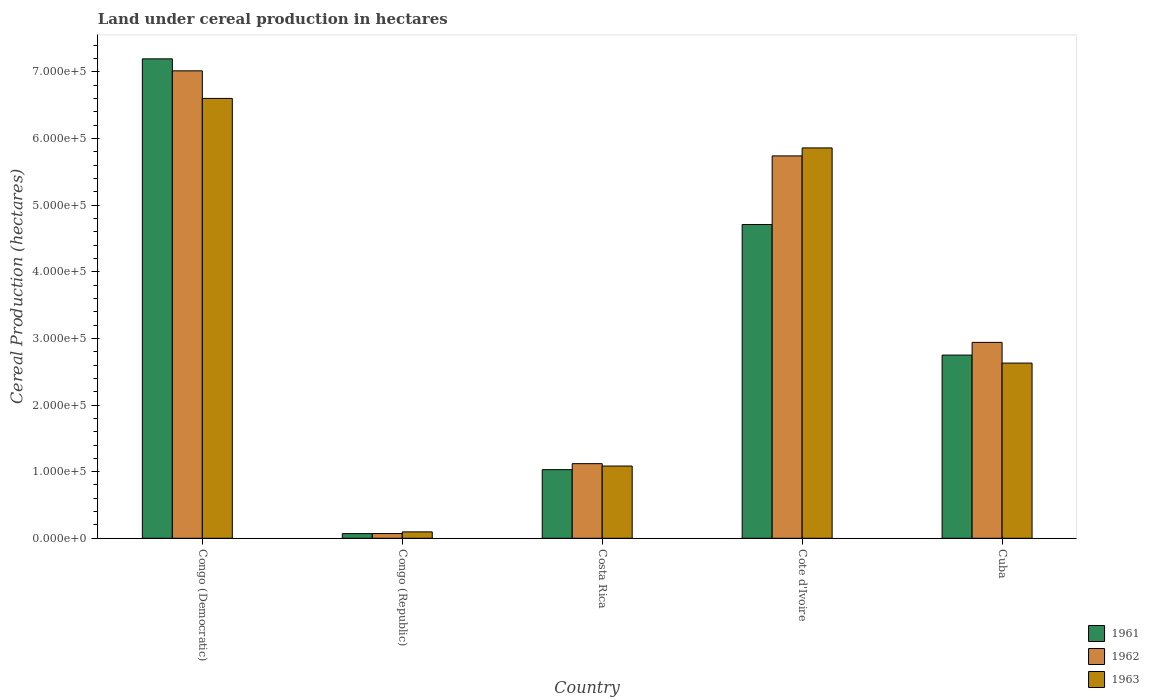How many groups of bars are there?
Make the answer very short. 5. Are the number of bars per tick equal to the number of legend labels?
Provide a short and direct response. Yes. How many bars are there on the 1st tick from the right?
Provide a succinct answer. 3. What is the label of the 2nd group of bars from the left?
Keep it short and to the point. Congo (Republic). What is the land under cereal production in 1962 in Cote d'Ivoire?
Your answer should be compact. 5.74e+05. Across all countries, what is the maximum land under cereal production in 1961?
Provide a succinct answer. 7.20e+05. Across all countries, what is the minimum land under cereal production in 1963?
Keep it short and to the point. 9600. In which country was the land under cereal production in 1961 maximum?
Give a very brief answer. Congo (Democratic). In which country was the land under cereal production in 1962 minimum?
Give a very brief answer. Congo (Republic). What is the total land under cereal production in 1961 in the graph?
Offer a very short reply. 1.58e+06. What is the difference between the land under cereal production in 1963 in Congo (Democratic) and that in Cote d'Ivoire?
Your answer should be compact. 7.43e+04. What is the difference between the land under cereal production in 1963 in Congo (Democratic) and the land under cereal production in 1961 in Costa Rica?
Provide a short and direct response. 5.57e+05. What is the average land under cereal production in 1963 per country?
Offer a very short reply. 3.25e+05. What is the difference between the land under cereal production of/in 1963 and land under cereal production of/in 1962 in Congo (Democratic)?
Offer a terse response. -4.14e+04. What is the ratio of the land under cereal production in 1962 in Congo (Republic) to that in Cuba?
Provide a succinct answer. 0.02. Is the difference between the land under cereal production in 1963 in Congo (Democratic) and Congo (Republic) greater than the difference between the land under cereal production in 1962 in Congo (Democratic) and Congo (Republic)?
Your response must be concise. No. What is the difference between the highest and the second highest land under cereal production in 1961?
Your answer should be compact. 1.96e+05. What is the difference between the highest and the lowest land under cereal production in 1962?
Offer a very short reply. 6.95e+05. What does the 3rd bar from the left in Cuba represents?
Provide a succinct answer. 1963. What does the 3rd bar from the right in Congo (Democratic) represents?
Make the answer very short. 1961. Is it the case that in every country, the sum of the land under cereal production in 1961 and land under cereal production in 1962 is greater than the land under cereal production in 1963?
Your answer should be compact. Yes. How many countries are there in the graph?
Offer a terse response. 5. What is the difference between two consecutive major ticks on the Y-axis?
Offer a terse response. 1.00e+05. Are the values on the major ticks of Y-axis written in scientific E-notation?
Your response must be concise. Yes. Does the graph contain any zero values?
Provide a succinct answer. No. Does the graph contain grids?
Offer a very short reply. No. Where does the legend appear in the graph?
Your answer should be compact. Bottom right. What is the title of the graph?
Provide a short and direct response. Land under cereal production in hectares. What is the label or title of the Y-axis?
Your answer should be very brief. Cereal Production (hectares). What is the Cereal Production (hectares) in 1961 in Congo (Democratic)?
Your answer should be very brief. 7.20e+05. What is the Cereal Production (hectares) of 1962 in Congo (Democratic)?
Ensure brevity in your answer.  7.02e+05. What is the Cereal Production (hectares) of 1963 in Congo (Democratic)?
Make the answer very short. 6.60e+05. What is the Cereal Production (hectares) in 1961 in Congo (Republic)?
Your response must be concise. 7000. What is the Cereal Production (hectares) in 1962 in Congo (Republic)?
Provide a succinct answer. 7100. What is the Cereal Production (hectares) in 1963 in Congo (Republic)?
Your answer should be compact. 9600. What is the Cereal Production (hectares) in 1961 in Costa Rica?
Provide a succinct answer. 1.03e+05. What is the Cereal Production (hectares) of 1962 in Costa Rica?
Offer a very short reply. 1.12e+05. What is the Cereal Production (hectares) of 1963 in Costa Rica?
Your answer should be compact. 1.08e+05. What is the Cereal Production (hectares) of 1961 in Cote d'Ivoire?
Give a very brief answer. 4.71e+05. What is the Cereal Production (hectares) of 1962 in Cote d'Ivoire?
Your answer should be very brief. 5.74e+05. What is the Cereal Production (hectares) of 1963 in Cote d'Ivoire?
Provide a short and direct response. 5.86e+05. What is the Cereal Production (hectares) in 1961 in Cuba?
Ensure brevity in your answer.  2.75e+05. What is the Cereal Production (hectares) of 1962 in Cuba?
Your answer should be compact. 2.94e+05. What is the Cereal Production (hectares) of 1963 in Cuba?
Give a very brief answer. 2.63e+05. Across all countries, what is the maximum Cereal Production (hectares) in 1961?
Provide a short and direct response. 7.20e+05. Across all countries, what is the maximum Cereal Production (hectares) of 1962?
Provide a short and direct response. 7.02e+05. Across all countries, what is the maximum Cereal Production (hectares) of 1963?
Your answer should be very brief. 6.60e+05. Across all countries, what is the minimum Cereal Production (hectares) in 1961?
Provide a short and direct response. 7000. Across all countries, what is the minimum Cereal Production (hectares) in 1962?
Make the answer very short. 7100. Across all countries, what is the minimum Cereal Production (hectares) of 1963?
Offer a very short reply. 9600. What is the total Cereal Production (hectares) in 1961 in the graph?
Provide a short and direct response. 1.58e+06. What is the total Cereal Production (hectares) of 1962 in the graph?
Your response must be concise. 1.69e+06. What is the total Cereal Production (hectares) of 1963 in the graph?
Offer a terse response. 1.63e+06. What is the difference between the Cereal Production (hectares) in 1961 in Congo (Democratic) and that in Congo (Republic)?
Your response must be concise. 7.13e+05. What is the difference between the Cereal Production (hectares) of 1962 in Congo (Democratic) and that in Congo (Republic)?
Provide a short and direct response. 6.95e+05. What is the difference between the Cereal Production (hectares) in 1963 in Congo (Democratic) and that in Congo (Republic)?
Keep it short and to the point. 6.51e+05. What is the difference between the Cereal Production (hectares) of 1961 in Congo (Democratic) and that in Costa Rica?
Give a very brief answer. 6.17e+05. What is the difference between the Cereal Production (hectares) in 1962 in Congo (Democratic) and that in Costa Rica?
Your response must be concise. 5.90e+05. What is the difference between the Cereal Production (hectares) of 1963 in Congo (Democratic) and that in Costa Rica?
Offer a very short reply. 5.52e+05. What is the difference between the Cereal Production (hectares) in 1961 in Congo (Democratic) and that in Cote d'Ivoire?
Ensure brevity in your answer.  2.49e+05. What is the difference between the Cereal Production (hectares) in 1962 in Congo (Democratic) and that in Cote d'Ivoire?
Your response must be concise. 1.28e+05. What is the difference between the Cereal Production (hectares) of 1963 in Congo (Democratic) and that in Cote d'Ivoire?
Your response must be concise. 7.43e+04. What is the difference between the Cereal Production (hectares) of 1961 in Congo (Democratic) and that in Cuba?
Ensure brevity in your answer.  4.45e+05. What is the difference between the Cereal Production (hectares) in 1962 in Congo (Democratic) and that in Cuba?
Your answer should be very brief. 4.08e+05. What is the difference between the Cereal Production (hectares) of 1963 in Congo (Democratic) and that in Cuba?
Provide a short and direct response. 3.97e+05. What is the difference between the Cereal Production (hectares) of 1961 in Congo (Republic) and that in Costa Rica?
Provide a short and direct response. -9.60e+04. What is the difference between the Cereal Production (hectares) of 1962 in Congo (Republic) and that in Costa Rica?
Offer a terse response. -1.05e+05. What is the difference between the Cereal Production (hectares) of 1963 in Congo (Republic) and that in Costa Rica?
Give a very brief answer. -9.88e+04. What is the difference between the Cereal Production (hectares) of 1961 in Congo (Republic) and that in Cote d'Ivoire?
Your answer should be very brief. -4.64e+05. What is the difference between the Cereal Production (hectares) in 1962 in Congo (Republic) and that in Cote d'Ivoire?
Offer a terse response. -5.67e+05. What is the difference between the Cereal Production (hectares) of 1963 in Congo (Republic) and that in Cote d'Ivoire?
Offer a terse response. -5.76e+05. What is the difference between the Cereal Production (hectares) of 1961 in Congo (Republic) and that in Cuba?
Your answer should be very brief. -2.68e+05. What is the difference between the Cereal Production (hectares) in 1962 in Congo (Republic) and that in Cuba?
Offer a terse response. -2.87e+05. What is the difference between the Cereal Production (hectares) of 1963 in Congo (Republic) and that in Cuba?
Offer a very short reply. -2.53e+05. What is the difference between the Cereal Production (hectares) of 1961 in Costa Rica and that in Cote d'Ivoire?
Offer a terse response. -3.68e+05. What is the difference between the Cereal Production (hectares) of 1962 in Costa Rica and that in Cote d'Ivoire?
Your answer should be compact. -4.62e+05. What is the difference between the Cereal Production (hectares) in 1963 in Costa Rica and that in Cote d'Ivoire?
Your response must be concise. -4.78e+05. What is the difference between the Cereal Production (hectares) of 1961 in Costa Rica and that in Cuba?
Your answer should be compact. -1.72e+05. What is the difference between the Cereal Production (hectares) of 1962 in Costa Rica and that in Cuba?
Provide a short and direct response. -1.82e+05. What is the difference between the Cereal Production (hectares) in 1963 in Costa Rica and that in Cuba?
Offer a very short reply. -1.55e+05. What is the difference between the Cereal Production (hectares) in 1961 in Cote d'Ivoire and that in Cuba?
Offer a very short reply. 1.96e+05. What is the difference between the Cereal Production (hectares) in 1962 in Cote d'Ivoire and that in Cuba?
Keep it short and to the point. 2.80e+05. What is the difference between the Cereal Production (hectares) of 1963 in Cote d'Ivoire and that in Cuba?
Make the answer very short. 3.23e+05. What is the difference between the Cereal Production (hectares) in 1961 in Congo (Democratic) and the Cereal Production (hectares) in 1962 in Congo (Republic)?
Offer a terse response. 7.13e+05. What is the difference between the Cereal Production (hectares) in 1961 in Congo (Democratic) and the Cereal Production (hectares) in 1963 in Congo (Republic)?
Ensure brevity in your answer.  7.10e+05. What is the difference between the Cereal Production (hectares) of 1962 in Congo (Democratic) and the Cereal Production (hectares) of 1963 in Congo (Republic)?
Ensure brevity in your answer.  6.92e+05. What is the difference between the Cereal Production (hectares) of 1961 in Congo (Democratic) and the Cereal Production (hectares) of 1962 in Costa Rica?
Offer a very short reply. 6.08e+05. What is the difference between the Cereal Production (hectares) of 1961 in Congo (Democratic) and the Cereal Production (hectares) of 1963 in Costa Rica?
Give a very brief answer. 6.11e+05. What is the difference between the Cereal Production (hectares) of 1962 in Congo (Democratic) and the Cereal Production (hectares) of 1963 in Costa Rica?
Your response must be concise. 5.93e+05. What is the difference between the Cereal Production (hectares) of 1961 in Congo (Democratic) and the Cereal Production (hectares) of 1962 in Cote d'Ivoire?
Your answer should be compact. 1.46e+05. What is the difference between the Cereal Production (hectares) in 1961 in Congo (Democratic) and the Cereal Production (hectares) in 1963 in Cote d'Ivoire?
Offer a terse response. 1.34e+05. What is the difference between the Cereal Production (hectares) in 1962 in Congo (Democratic) and the Cereal Production (hectares) in 1963 in Cote d'Ivoire?
Offer a very short reply. 1.16e+05. What is the difference between the Cereal Production (hectares) of 1961 in Congo (Democratic) and the Cereal Production (hectares) of 1962 in Cuba?
Your answer should be very brief. 4.26e+05. What is the difference between the Cereal Production (hectares) in 1961 in Congo (Democratic) and the Cereal Production (hectares) in 1963 in Cuba?
Offer a terse response. 4.57e+05. What is the difference between the Cereal Production (hectares) in 1962 in Congo (Democratic) and the Cereal Production (hectares) in 1963 in Cuba?
Your answer should be compact. 4.39e+05. What is the difference between the Cereal Production (hectares) in 1961 in Congo (Republic) and the Cereal Production (hectares) in 1962 in Costa Rica?
Your answer should be compact. -1.05e+05. What is the difference between the Cereal Production (hectares) of 1961 in Congo (Republic) and the Cereal Production (hectares) of 1963 in Costa Rica?
Make the answer very short. -1.01e+05. What is the difference between the Cereal Production (hectares) in 1962 in Congo (Republic) and the Cereal Production (hectares) in 1963 in Costa Rica?
Your answer should be very brief. -1.01e+05. What is the difference between the Cereal Production (hectares) in 1961 in Congo (Republic) and the Cereal Production (hectares) in 1962 in Cote d'Ivoire?
Make the answer very short. -5.67e+05. What is the difference between the Cereal Production (hectares) in 1961 in Congo (Republic) and the Cereal Production (hectares) in 1963 in Cote d'Ivoire?
Make the answer very short. -5.79e+05. What is the difference between the Cereal Production (hectares) of 1962 in Congo (Republic) and the Cereal Production (hectares) of 1963 in Cote d'Ivoire?
Your answer should be very brief. -5.79e+05. What is the difference between the Cereal Production (hectares) of 1961 in Congo (Republic) and the Cereal Production (hectares) of 1962 in Cuba?
Your response must be concise. -2.87e+05. What is the difference between the Cereal Production (hectares) of 1961 in Congo (Republic) and the Cereal Production (hectares) of 1963 in Cuba?
Keep it short and to the point. -2.56e+05. What is the difference between the Cereal Production (hectares) in 1962 in Congo (Republic) and the Cereal Production (hectares) in 1963 in Cuba?
Your answer should be compact. -2.56e+05. What is the difference between the Cereal Production (hectares) in 1961 in Costa Rica and the Cereal Production (hectares) in 1962 in Cote d'Ivoire?
Provide a short and direct response. -4.71e+05. What is the difference between the Cereal Production (hectares) of 1961 in Costa Rica and the Cereal Production (hectares) of 1963 in Cote d'Ivoire?
Keep it short and to the point. -4.83e+05. What is the difference between the Cereal Production (hectares) of 1962 in Costa Rica and the Cereal Production (hectares) of 1963 in Cote d'Ivoire?
Ensure brevity in your answer.  -4.74e+05. What is the difference between the Cereal Production (hectares) in 1961 in Costa Rica and the Cereal Production (hectares) in 1962 in Cuba?
Ensure brevity in your answer.  -1.91e+05. What is the difference between the Cereal Production (hectares) in 1961 in Costa Rica and the Cereal Production (hectares) in 1963 in Cuba?
Provide a short and direct response. -1.60e+05. What is the difference between the Cereal Production (hectares) of 1962 in Costa Rica and the Cereal Production (hectares) of 1963 in Cuba?
Give a very brief answer. -1.51e+05. What is the difference between the Cereal Production (hectares) in 1961 in Cote d'Ivoire and the Cereal Production (hectares) in 1962 in Cuba?
Provide a succinct answer. 1.77e+05. What is the difference between the Cereal Production (hectares) in 1961 in Cote d'Ivoire and the Cereal Production (hectares) in 1963 in Cuba?
Offer a very short reply. 2.08e+05. What is the difference between the Cereal Production (hectares) of 1962 in Cote d'Ivoire and the Cereal Production (hectares) of 1963 in Cuba?
Your answer should be compact. 3.11e+05. What is the average Cereal Production (hectares) in 1961 per country?
Your answer should be compact. 3.15e+05. What is the average Cereal Production (hectares) of 1962 per country?
Your answer should be compact. 3.38e+05. What is the average Cereal Production (hectares) in 1963 per country?
Offer a very short reply. 3.25e+05. What is the difference between the Cereal Production (hectares) of 1961 and Cereal Production (hectares) of 1962 in Congo (Democratic)?
Provide a succinct answer. 1.80e+04. What is the difference between the Cereal Production (hectares) of 1961 and Cereal Production (hectares) of 1963 in Congo (Democratic)?
Offer a terse response. 5.94e+04. What is the difference between the Cereal Production (hectares) of 1962 and Cereal Production (hectares) of 1963 in Congo (Democratic)?
Provide a short and direct response. 4.14e+04. What is the difference between the Cereal Production (hectares) of 1961 and Cereal Production (hectares) of 1962 in Congo (Republic)?
Your response must be concise. -100. What is the difference between the Cereal Production (hectares) of 1961 and Cereal Production (hectares) of 1963 in Congo (Republic)?
Offer a terse response. -2600. What is the difference between the Cereal Production (hectares) of 1962 and Cereal Production (hectares) of 1963 in Congo (Republic)?
Your response must be concise. -2500. What is the difference between the Cereal Production (hectares) of 1961 and Cereal Production (hectares) of 1962 in Costa Rica?
Your answer should be compact. -9000. What is the difference between the Cereal Production (hectares) in 1961 and Cereal Production (hectares) in 1963 in Costa Rica?
Provide a succinct answer. -5450. What is the difference between the Cereal Production (hectares) in 1962 and Cereal Production (hectares) in 1963 in Costa Rica?
Provide a succinct answer. 3550. What is the difference between the Cereal Production (hectares) of 1961 and Cereal Production (hectares) of 1962 in Cote d'Ivoire?
Offer a terse response. -1.03e+05. What is the difference between the Cereal Production (hectares) of 1961 and Cereal Production (hectares) of 1963 in Cote d'Ivoire?
Your answer should be compact. -1.15e+05. What is the difference between the Cereal Production (hectares) of 1962 and Cereal Production (hectares) of 1963 in Cote d'Ivoire?
Your response must be concise. -1.20e+04. What is the difference between the Cereal Production (hectares) in 1961 and Cereal Production (hectares) in 1962 in Cuba?
Offer a very short reply. -1.91e+04. What is the difference between the Cereal Production (hectares) of 1961 and Cereal Production (hectares) of 1963 in Cuba?
Provide a succinct answer. 1.20e+04. What is the difference between the Cereal Production (hectares) in 1962 and Cereal Production (hectares) in 1963 in Cuba?
Your response must be concise. 3.11e+04. What is the ratio of the Cereal Production (hectares) of 1961 in Congo (Democratic) to that in Congo (Republic)?
Keep it short and to the point. 102.81. What is the ratio of the Cereal Production (hectares) in 1962 in Congo (Democratic) to that in Congo (Republic)?
Your answer should be very brief. 98.83. What is the ratio of the Cereal Production (hectares) in 1963 in Congo (Democratic) to that in Congo (Republic)?
Make the answer very short. 68.78. What is the ratio of the Cereal Production (hectares) of 1961 in Congo (Democratic) to that in Costa Rica?
Provide a succinct answer. 6.99. What is the ratio of the Cereal Production (hectares) of 1962 in Congo (Democratic) to that in Costa Rica?
Your response must be concise. 6.27. What is the ratio of the Cereal Production (hectares) in 1963 in Congo (Democratic) to that in Costa Rica?
Your response must be concise. 6.09. What is the ratio of the Cereal Production (hectares) in 1961 in Congo (Democratic) to that in Cote d'Ivoire?
Give a very brief answer. 1.53. What is the ratio of the Cereal Production (hectares) of 1962 in Congo (Democratic) to that in Cote d'Ivoire?
Keep it short and to the point. 1.22. What is the ratio of the Cereal Production (hectares) in 1963 in Congo (Democratic) to that in Cote d'Ivoire?
Your answer should be compact. 1.13. What is the ratio of the Cereal Production (hectares) in 1961 in Congo (Democratic) to that in Cuba?
Provide a succinct answer. 2.62. What is the ratio of the Cereal Production (hectares) of 1962 in Congo (Democratic) to that in Cuba?
Make the answer very short. 2.39. What is the ratio of the Cereal Production (hectares) in 1963 in Congo (Democratic) to that in Cuba?
Offer a terse response. 2.51. What is the ratio of the Cereal Production (hectares) of 1961 in Congo (Republic) to that in Costa Rica?
Offer a terse response. 0.07. What is the ratio of the Cereal Production (hectares) in 1962 in Congo (Republic) to that in Costa Rica?
Give a very brief answer. 0.06. What is the ratio of the Cereal Production (hectares) in 1963 in Congo (Republic) to that in Costa Rica?
Keep it short and to the point. 0.09. What is the ratio of the Cereal Production (hectares) in 1961 in Congo (Republic) to that in Cote d'Ivoire?
Provide a succinct answer. 0.01. What is the ratio of the Cereal Production (hectares) in 1962 in Congo (Republic) to that in Cote d'Ivoire?
Make the answer very short. 0.01. What is the ratio of the Cereal Production (hectares) of 1963 in Congo (Republic) to that in Cote d'Ivoire?
Offer a terse response. 0.02. What is the ratio of the Cereal Production (hectares) in 1961 in Congo (Republic) to that in Cuba?
Your answer should be compact. 0.03. What is the ratio of the Cereal Production (hectares) of 1962 in Congo (Republic) to that in Cuba?
Your response must be concise. 0.02. What is the ratio of the Cereal Production (hectares) in 1963 in Congo (Republic) to that in Cuba?
Give a very brief answer. 0.04. What is the ratio of the Cereal Production (hectares) in 1961 in Costa Rica to that in Cote d'Ivoire?
Ensure brevity in your answer.  0.22. What is the ratio of the Cereal Production (hectares) of 1962 in Costa Rica to that in Cote d'Ivoire?
Keep it short and to the point. 0.2. What is the ratio of the Cereal Production (hectares) in 1963 in Costa Rica to that in Cote d'Ivoire?
Offer a terse response. 0.19. What is the ratio of the Cereal Production (hectares) of 1961 in Costa Rica to that in Cuba?
Offer a very short reply. 0.37. What is the ratio of the Cereal Production (hectares) of 1962 in Costa Rica to that in Cuba?
Keep it short and to the point. 0.38. What is the ratio of the Cereal Production (hectares) in 1963 in Costa Rica to that in Cuba?
Ensure brevity in your answer.  0.41. What is the ratio of the Cereal Production (hectares) in 1961 in Cote d'Ivoire to that in Cuba?
Your response must be concise. 1.71. What is the ratio of the Cereal Production (hectares) in 1962 in Cote d'Ivoire to that in Cuba?
Your answer should be compact. 1.95. What is the ratio of the Cereal Production (hectares) in 1963 in Cote d'Ivoire to that in Cuba?
Your answer should be very brief. 2.23. What is the difference between the highest and the second highest Cereal Production (hectares) in 1961?
Your response must be concise. 2.49e+05. What is the difference between the highest and the second highest Cereal Production (hectares) of 1962?
Your answer should be compact. 1.28e+05. What is the difference between the highest and the second highest Cereal Production (hectares) of 1963?
Give a very brief answer. 7.43e+04. What is the difference between the highest and the lowest Cereal Production (hectares) of 1961?
Keep it short and to the point. 7.13e+05. What is the difference between the highest and the lowest Cereal Production (hectares) in 1962?
Provide a succinct answer. 6.95e+05. What is the difference between the highest and the lowest Cereal Production (hectares) in 1963?
Your answer should be very brief. 6.51e+05. 